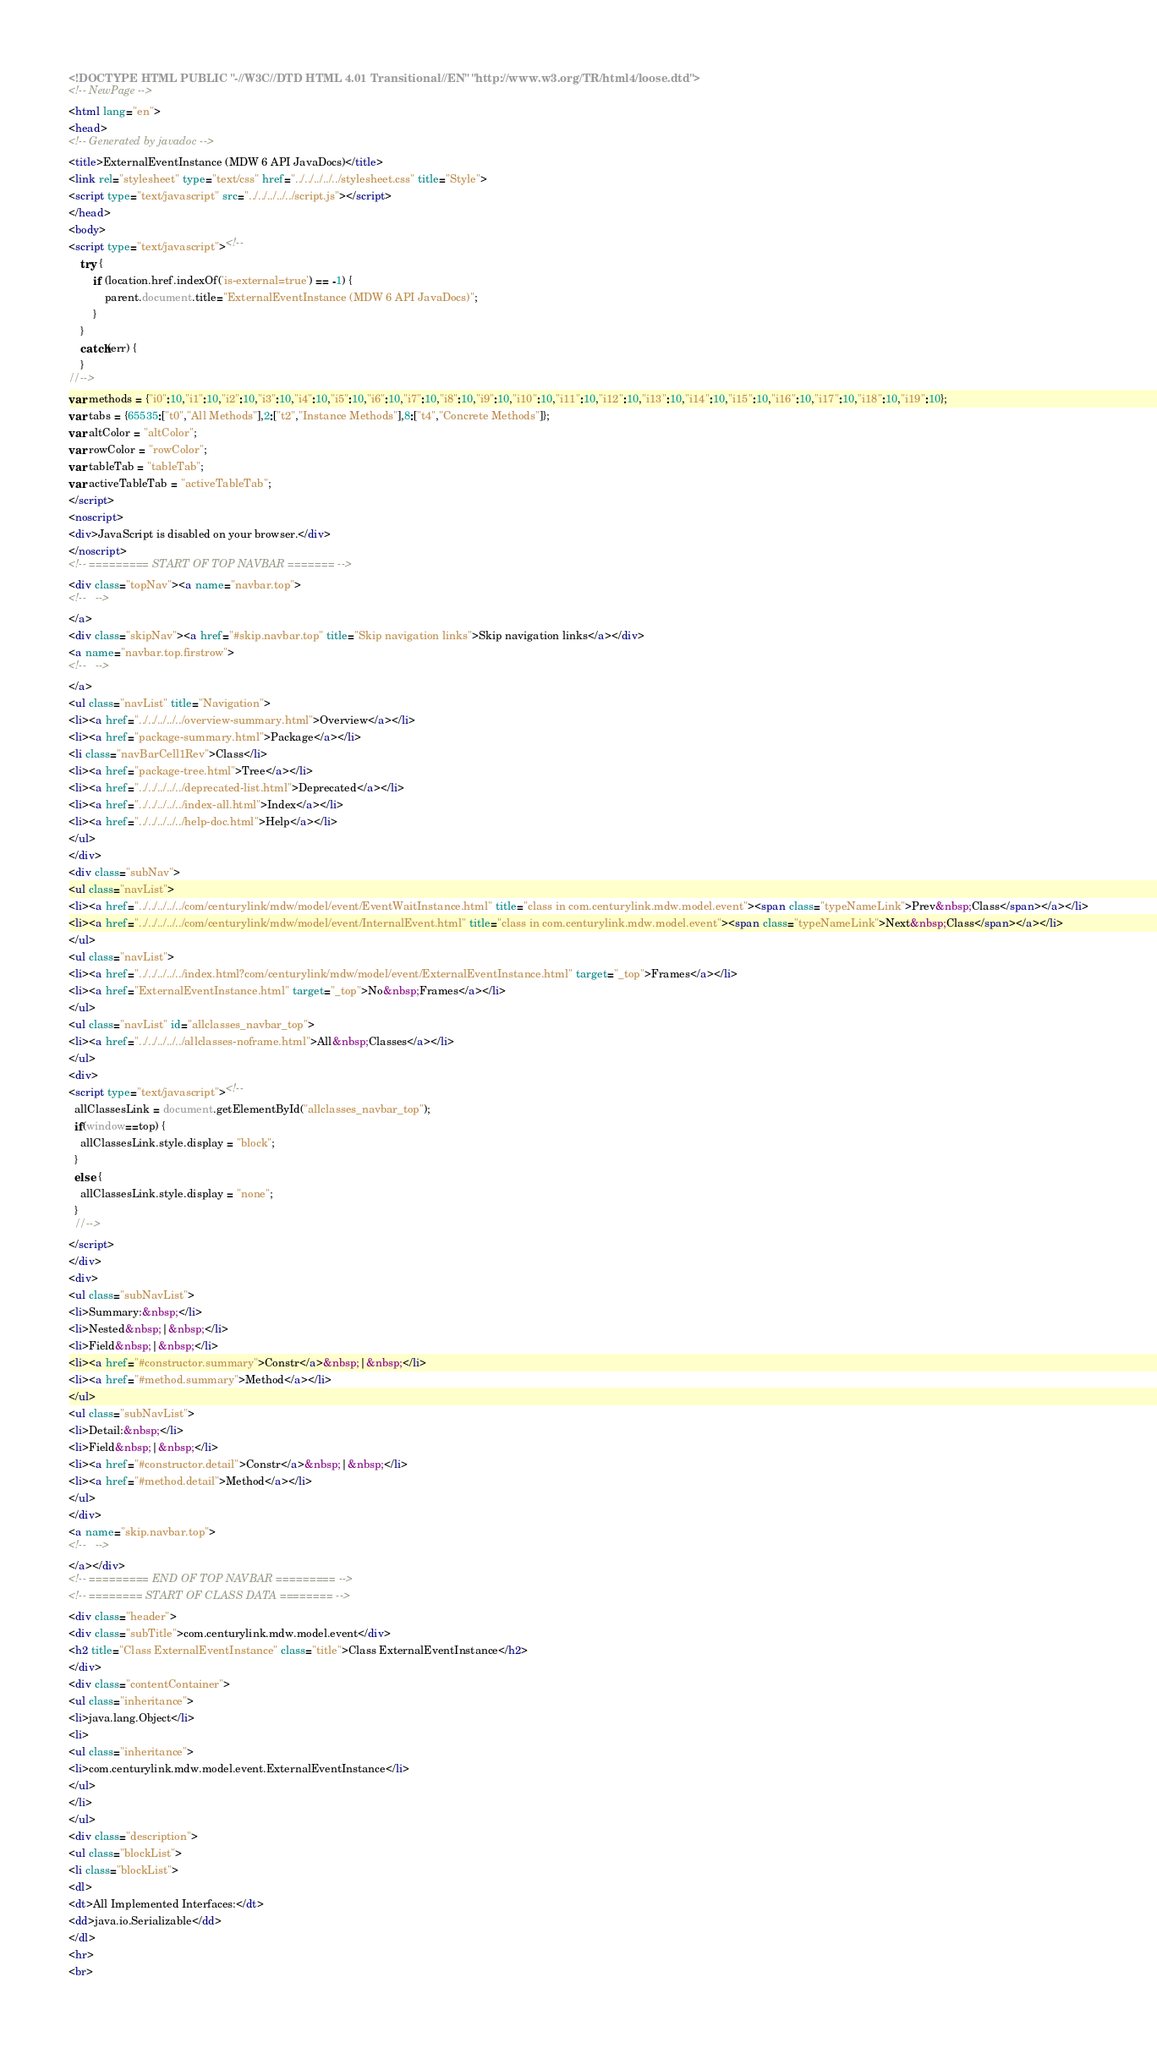Convert code to text. <code><loc_0><loc_0><loc_500><loc_500><_HTML_><!DOCTYPE HTML PUBLIC "-//W3C//DTD HTML 4.01 Transitional//EN" "http://www.w3.org/TR/html4/loose.dtd">
<!-- NewPage -->
<html lang="en">
<head>
<!-- Generated by javadoc -->
<title>ExternalEventInstance (MDW 6 API JavaDocs)</title>
<link rel="stylesheet" type="text/css" href="../../../../../stylesheet.css" title="Style">
<script type="text/javascript" src="../../../../../script.js"></script>
</head>
<body>
<script type="text/javascript"><!--
    try {
        if (location.href.indexOf('is-external=true') == -1) {
            parent.document.title="ExternalEventInstance (MDW 6 API JavaDocs)";
        }
    }
    catch(err) {
    }
//-->
var methods = {"i0":10,"i1":10,"i2":10,"i3":10,"i4":10,"i5":10,"i6":10,"i7":10,"i8":10,"i9":10,"i10":10,"i11":10,"i12":10,"i13":10,"i14":10,"i15":10,"i16":10,"i17":10,"i18":10,"i19":10};
var tabs = {65535:["t0","All Methods"],2:["t2","Instance Methods"],8:["t4","Concrete Methods"]};
var altColor = "altColor";
var rowColor = "rowColor";
var tableTab = "tableTab";
var activeTableTab = "activeTableTab";
</script>
<noscript>
<div>JavaScript is disabled on your browser.</div>
</noscript>
<!-- ========= START OF TOP NAVBAR ======= -->
<div class="topNav"><a name="navbar.top">
<!--   -->
</a>
<div class="skipNav"><a href="#skip.navbar.top" title="Skip navigation links">Skip navigation links</a></div>
<a name="navbar.top.firstrow">
<!--   -->
</a>
<ul class="navList" title="Navigation">
<li><a href="../../../../../overview-summary.html">Overview</a></li>
<li><a href="package-summary.html">Package</a></li>
<li class="navBarCell1Rev">Class</li>
<li><a href="package-tree.html">Tree</a></li>
<li><a href="../../../../../deprecated-list.html">Deprecated</a></li>
<li><a href="../../../../../index-all.html">Index</a></li>
<li><a href="../../../../../help-doc.html">Help</a></li>
</ul>
</div>
<div class="subNav">
<ul class="navList">
<li><a href="../../../../../com/centurylink/mdw/model/event/EventWaitInstance.html" title="class in com.centurylink.mdw.model.event"><span class="typeNameLink">Prev&nbsp;Class</span></a></li>
<li><a href="../../../../../com/centurylink/mdw/model/event/InternalEvent.html" title="class in com.centurylink.mdw.model.event"><span class="typeNameLink">Next&nbsp;Class</span></a></li>
</ul>
<ul class="navList">
<li><a href="../../../../../index.html?com/centurylink/mdw/model/event/ExternalEventInstance.html" target="_top">Frames</a></li>
<li><a href="ExternalEventInstance.html" target="_top">No&nbsp;Frames</a></li>
</ul>
<ul class="navList" id="allclasses_navbar_top">
<li><a href="../../../../../allclasses-noframe.html">All&nbsp;Classes</a></li>
</ul>
<div>
<script type="text/javascript"><!--
  allClassesLink = document.getElementById("allclasses_navbar_top");
  if(window==top) {
    allClassesLink.style.display = "block";
  }
  else {
    allClassesLink.style.display = "none";
  }
  //-->
</script>
</div>
<div>
<ul class="subNavList">
<li>Summary:&nbsp;</li>
<li>Nested&nbsp;|&nbsp;</li>
<li>Field&nbsp;|&nbsp;</li>
<li><a href="#constructor.summary">Constr</a>&nbsp;|&nbsp;</li>
<li><a href="#method.summary">Method</a></li>
</ul>
<ul class="subNavList">
<li>Detail:&nbsp;</li>
<li>Field&nbsp;|&nbsp;</li>
<li><a href="#constructor.detail">Constr</a>&nbsp;|&nbsp;</li>
<li><a href="#method.detail">Method</a></li>
</ul>
</div>
<a name="skip.navbar.top">
<!--   -->
</a></div>
<!-- ========= END OF TOP NAVBAR ========= -->
<!-- ======== START OF CLASS DATA ======== -->
<div class="header">
<div class="subTitle">com.centurylink.mdw.model.event</div>
<h2 title="Class ExternalEventInstance" class="title">Class ExternalEventInstance</h2>
</div>
<div class="contentContainer">
<ul class="inheritance">
<li>java.lang.Object</li>
<li>
<ul class="inheritance">
<li>com.centurylink.mdw.model.event.ExternalEventInstance</li>
</ul>
</li>
</ul>
<div class="description">
<ul class="blockList">
<li class="blockList">
<dl>
<dt>All Implemented Interfaces:</dt>
<dd>java.io.Serializable</dd>
</dl>
<hr>
<br></code> 